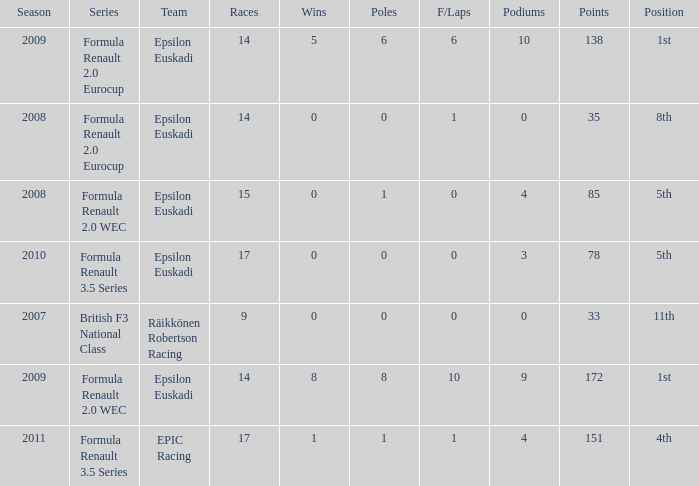What team was he on when he had 10 f/laps? Epsilon Euskadi. 